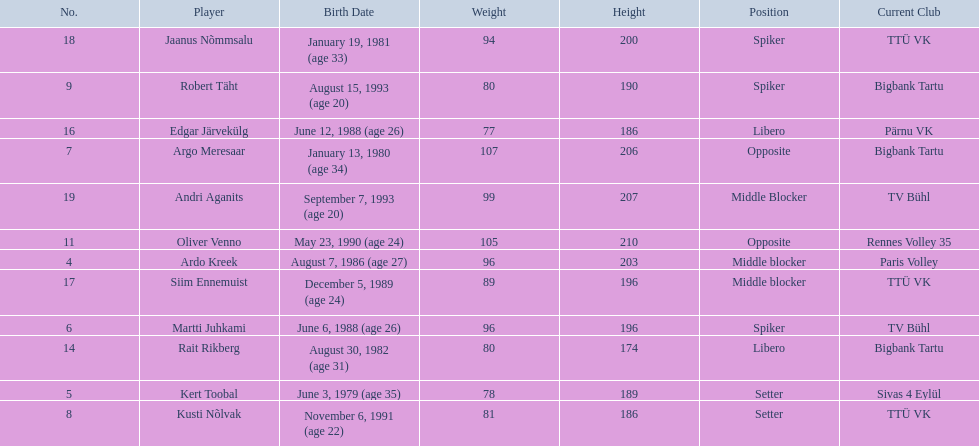Who are all of the players? Ardo Kreek, Kert Toobal, Martti Juhkami, Argo Meresaar, Kusti Nõlvak, Robert Täht, Oliver Venno, Rait Rikberg, Edgar Järvekülg, Siim Ennemuist, Jaanus Nõmmsalu, Andri Aganits. How tall are they? 203, 189, 196, 206, 186, 190, 210, 174, 186, 196, 200, 207. And which player is tallest? Oliver Venno. 